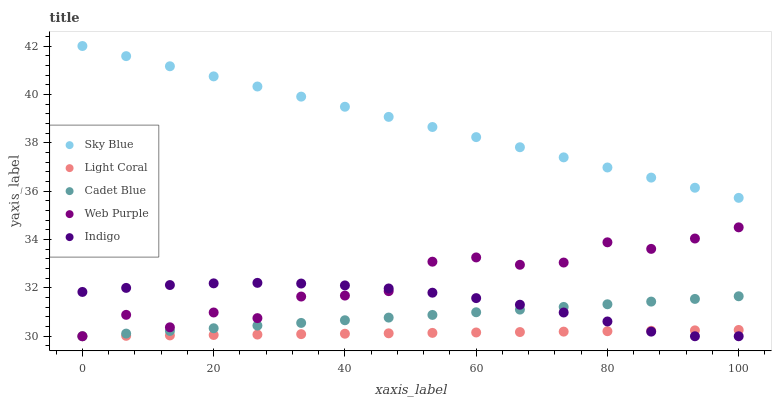Does Light Coral have the minimum area under the curve?
Answer yes or no. Yes. Does Sky Blue have the maximum area under the curve?
Answer yes or no. Yes. Does Web Purple have the minimum area under the curve?
Answer yes or no. No. Does Web Purple have the maximum area under the curve?
Answer yes or no. No. Is Light Coral the smoothest?
Answer yes or no. Yes. Is Web Purple the roughest?
Answer yes or no. Yes. Is Sky Blue the smoothest?
Answer yes or no. No. Is Sky Blue the roughest?
Answer yes or no. No. Does Light Coral have the lowest value?
Answer yes or no. Yes. Does Sky Blue have the lowest value?
Answer yes or no. No. Does Sky Blue have the highest value?
Answer yes or no. Yes. Does Web Purple have the highest value?
Answer yes or no. No. Is Indigo less than Sky Blue?
Answer yes or no. Yes. Is Sky Blue greater than Cadet Blue?
Answer yes or no. Yes. Does Indigo intersect Light Coral?
Answer yes or no. Yes. Is Indigo less than Light Coral?
Answer yes or no. No. Is Indigo greater than Light Coral?
Answer yes or no. No. Does Indigo intersect Sky Blue?
Answer yes or no. No. 